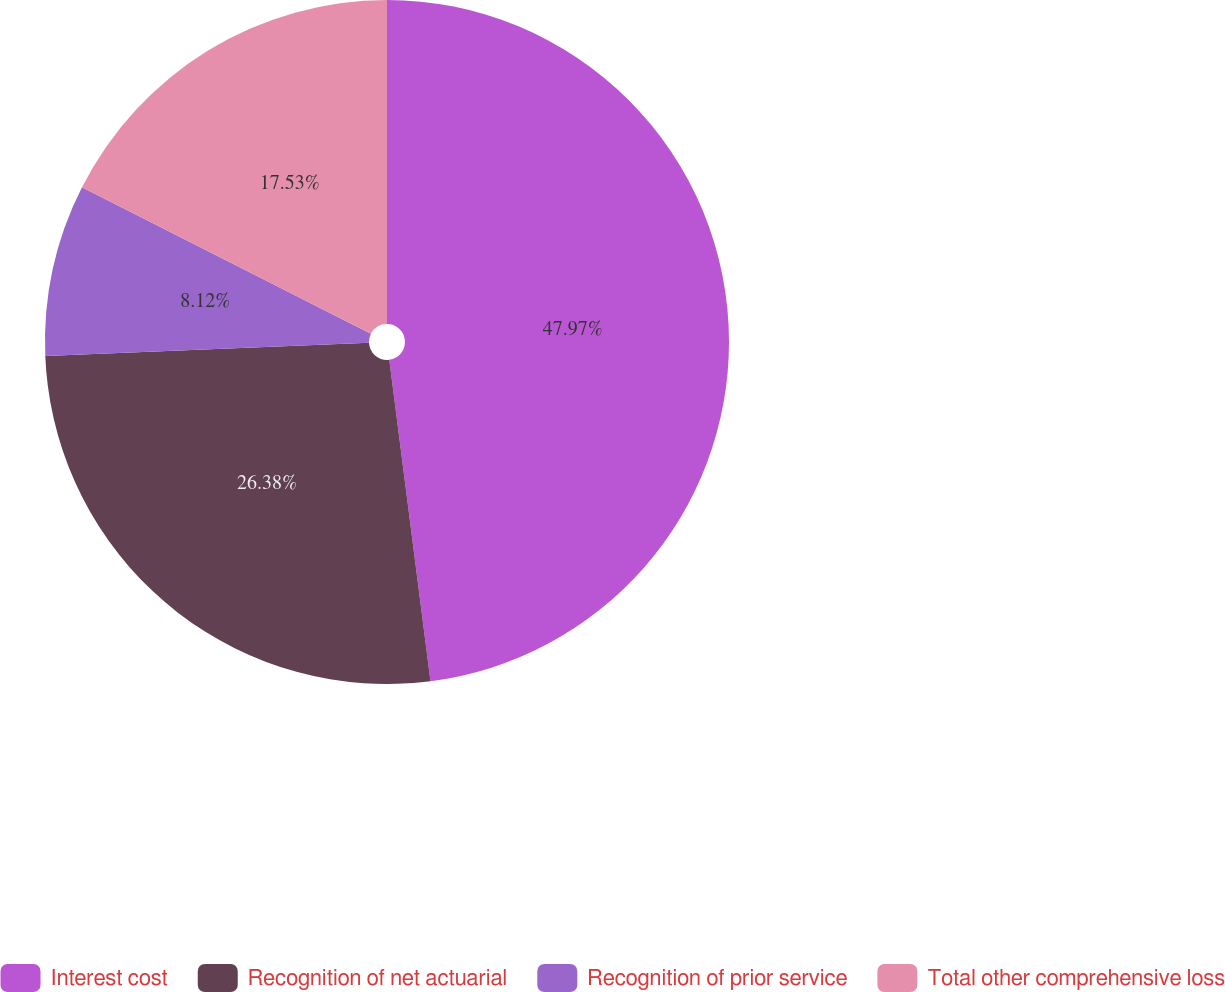Convert chart. <chart><loc_0><loc_0><loc_500><loc_500><pie_chart><fcel>Interest cost<fcel>Recognition of net actuarial<fcel>Recognition of prior service<fcel>Total other comprehensive loss<nl><fcel>47.97%<fcel>26.38%<fcel>8.12%<fcel>17.53%<nl></chart> 